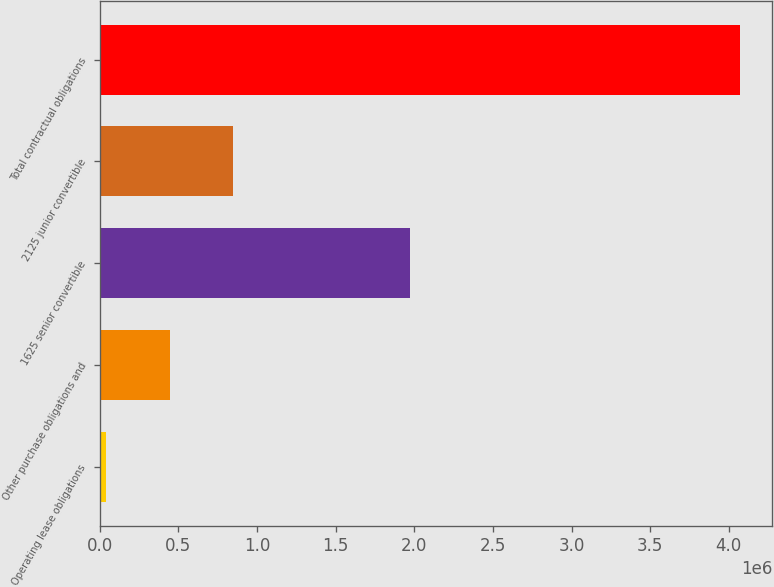Convert chart to OTSL. <chart><loc_0><loc_0><loc_500><loc_500><bar_chart><fcel>Operating lease obligations<fcel>Other purchase obligations and<fcel>1625 senior convertible<fcel>2125 junior convertible<fcel>Total contractual obligations<nl><fcel>41162<fcel>444373<fcel>1.97378e+06<fcel>847583<fcel>4.07327e+06<nl></chart> 